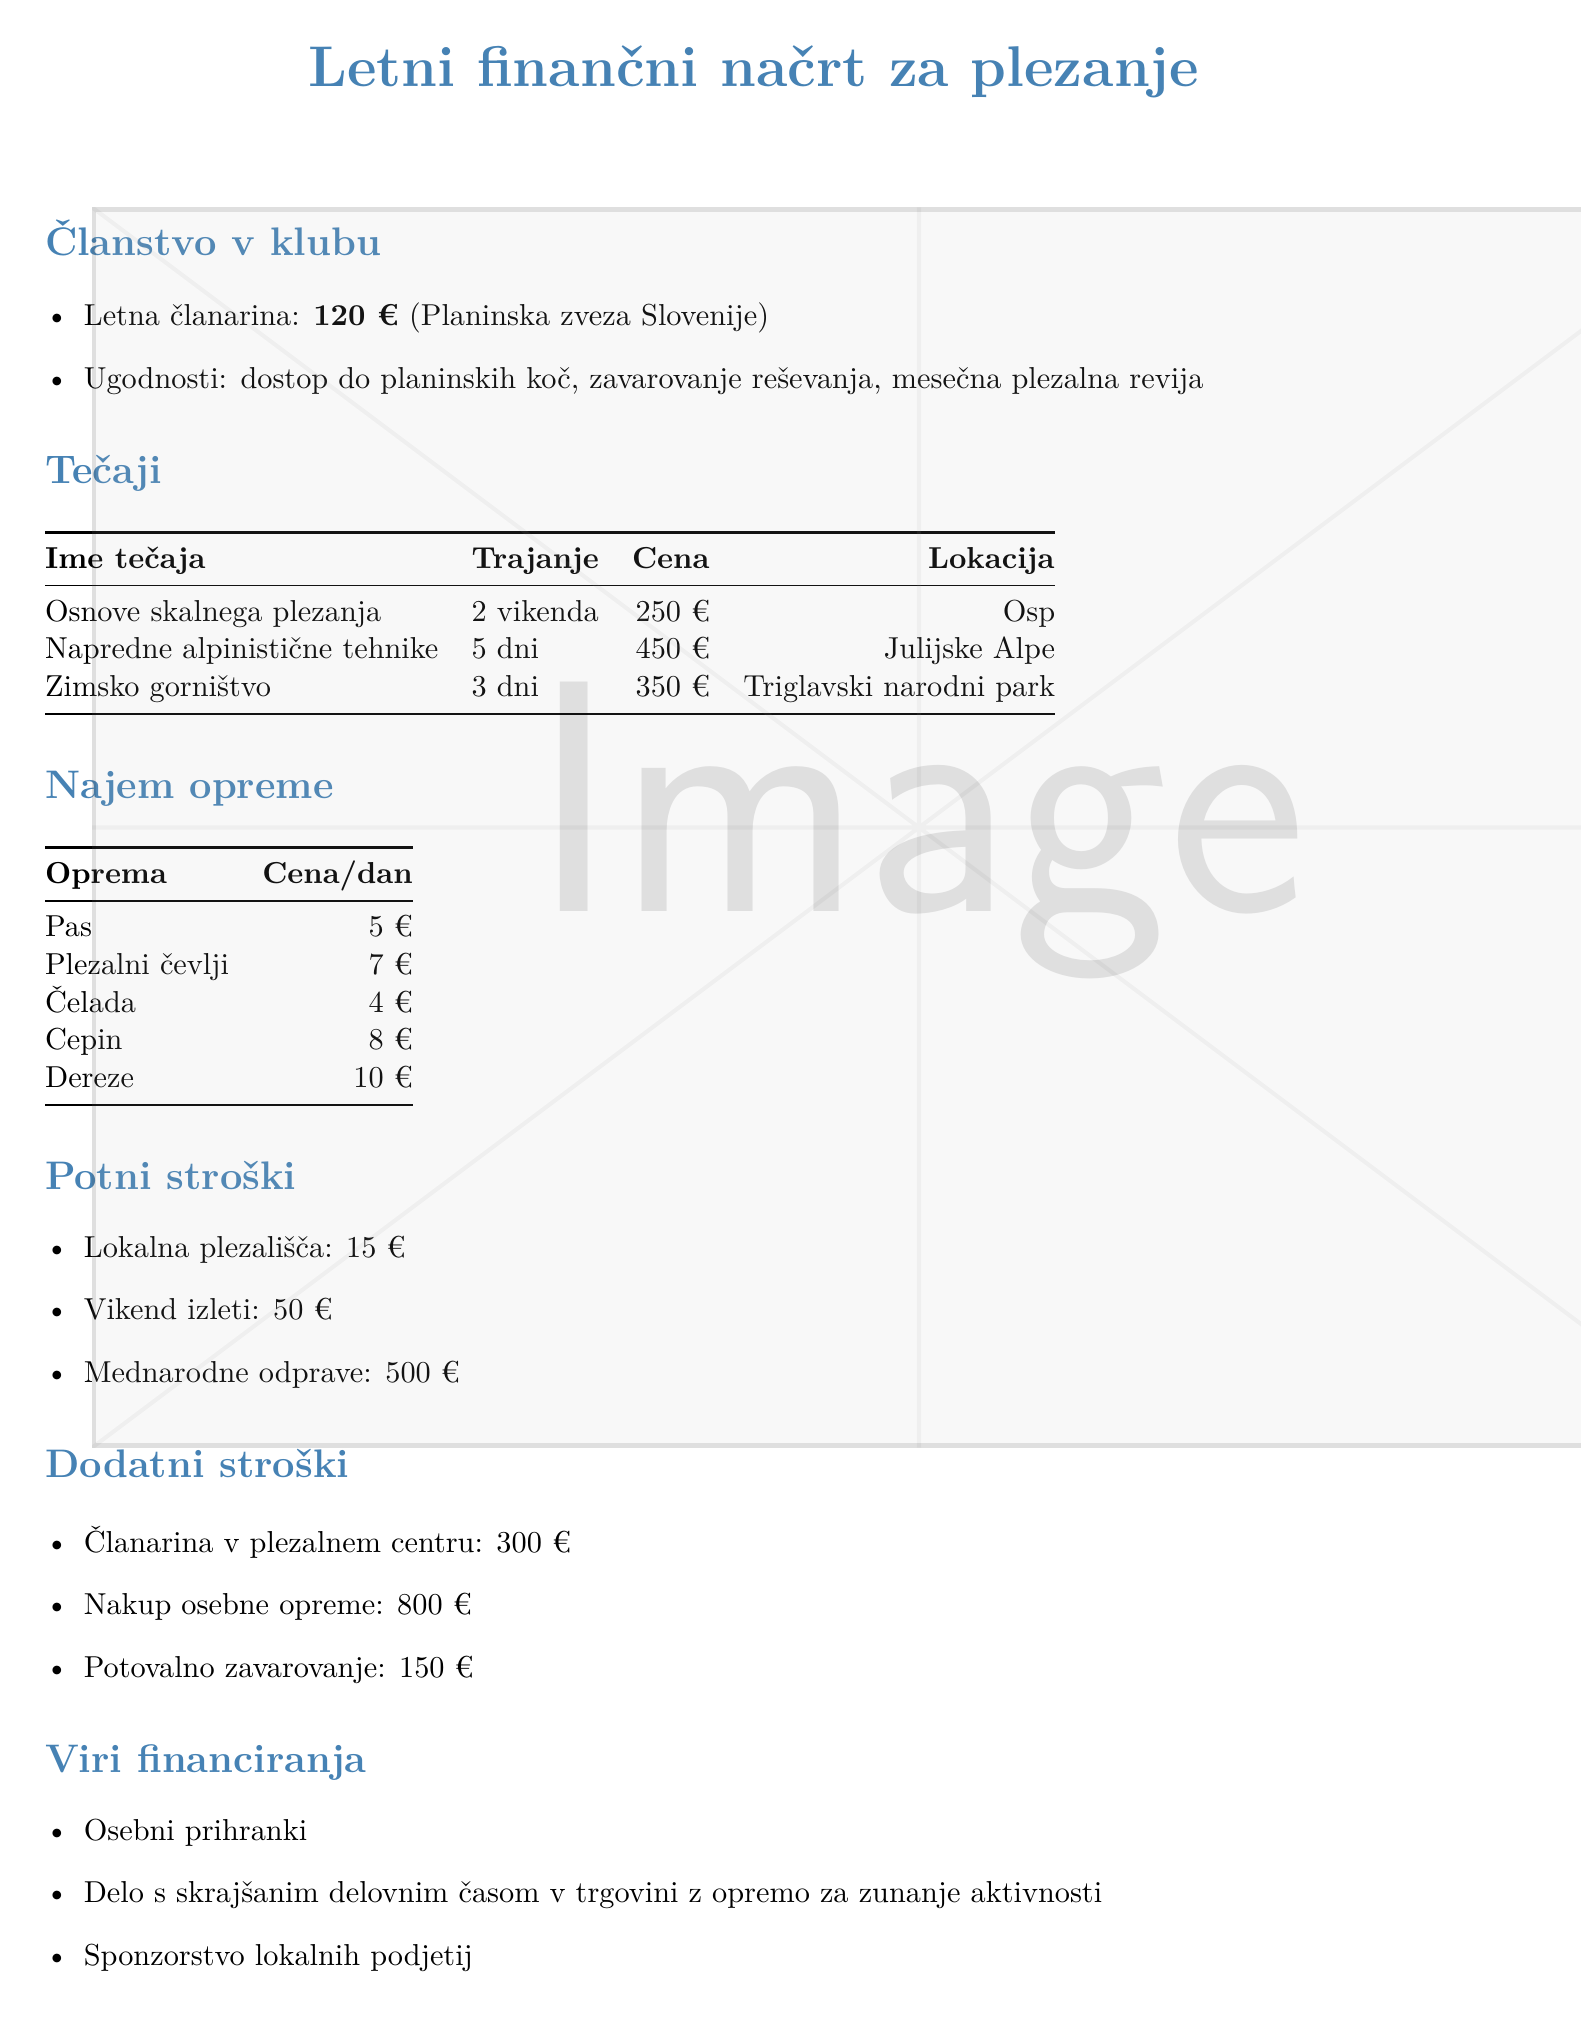What is the annual club membership fee? The document states that the annual fee for club membership is listed as 120 €.
Answer: 120 € How much does the "Zimsko gorništvo" course cost? The document provides the price for the "Zimsko gorništvo" course, which is 350 €.
Answer: 350 € What is the price per day for a helmet rental? The rental price for a helmet is specifically mentioned in the document as 4 €.
Answer: 4 € What is the total cost for a weekend trip? The document indicates the cost for a weekend trip is 50 €.
Answer: 50 € How many days does the "Napredne alpinistične tehnike" course last? According to the document, this course lasts for 5 days.
Answer: 5 days What are the sources of funding mentioned? The document lists sources of financing such as personal savings and part-time work.
Answer: Personal savings, part-time work What is the total cost of personal equipment purchase? The document explicitly states that the purchase of personal equipment costs 800 €.
Answer: 800 € What type of insurance is mentioned in the membership benefits? The document mentions rescue insurance as part of the membership benefits.
Answer: Rescue insurance How many courses are listed in the document? The document details three climbing courses available for members.
Answer: Three courses 